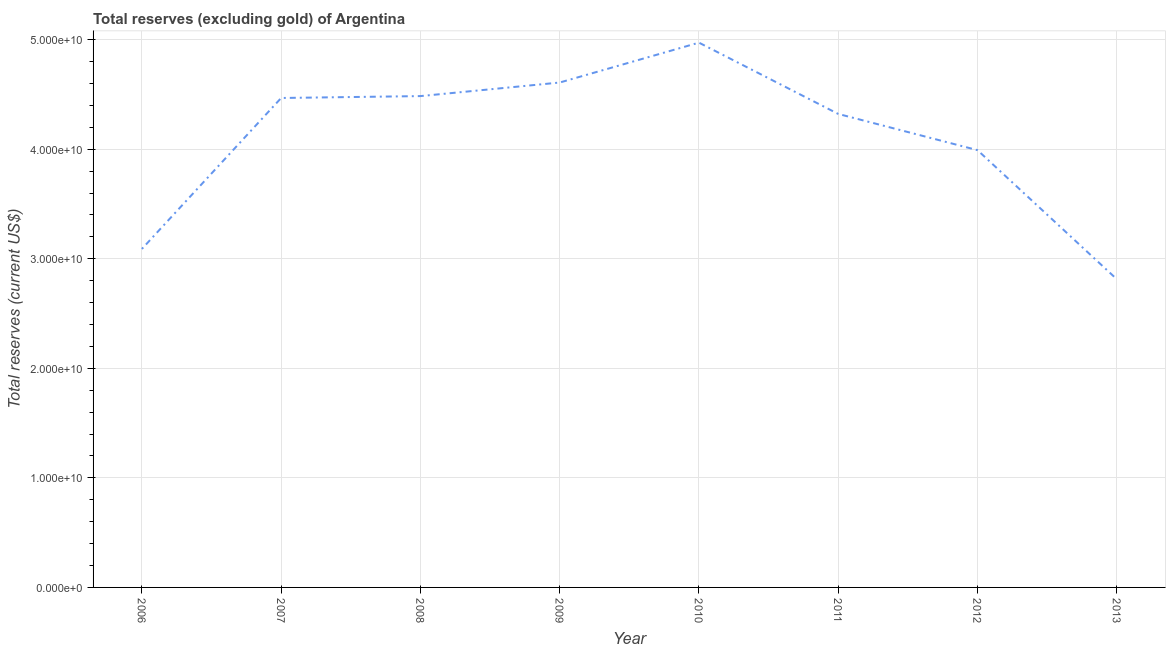What is the total reserves (excluding gold) in 2006?
Your answer should be very brief. 3.09e+1. Across all years, what is the maximum total reserves (excluding gold)?
Your answer should be very brief. 4.97e+1. Across all years, what is the minimum total reserves (excluding gold)?
Ensure brevity in your answer.  2.81e+1. What is the sum of the total reserves (excluding gold)?
Your answer should be compact. 3.28e+11. What is the difference between the total reserves (excluding gold) in 2006 and 2008?
Make the answer very short. -1.40e+1. What is the average total reserves (excluding gold) per year?
Keep it short and to the point. 4.09e+1. What is the median total reserves (excluding gold)?
Provide a short and direct response. 4.40e+1. What is the ratio of the total reserves (excluding gold) in 2007 to that in 2011?
Provide a short and direct response. 1.03. Is the difference between the total reserves (excluding gold) in 2006 and 2010 greater than the difference between any two years?
Give a very brief answer. No. What is the difference between the highest and the second highest total reserves (excluding gold)?
Provide a short and direct response. 3.64e+09. What is the difference between the highest and the lowest total reserves (excluding gold)?
Your answer should be compact. 2.16e+1. How many years are there in the graph?
Your answer should be very brief. 8. What is the difference between two consecutive major ticks on the Y-axis?
Ensure brevity in your answer.  1.00e+1. What is the title of the graph?
Provide a succinct answer. Total reserves (excluding gold) of Argentina. What is the label or title of the X-axis?
Your answer should be very brief. Year. What is the label or title of the Y-axis?
Ensure brevity in your answer.  Total reserves (current US$). What is the Total reserves (current US$) in 2006?
Your response must be concise. 3.09e+1. What is the Total reserves (current US$) of 2007?
Provide a succinct answer. 4.47e+1. What is the Total reserves (current US$) of 2008?
Offer a very short reply. 4.49e+1. What is the Total reserves (current US$) of 2009?
Your response must be concise. 4.61e+1. What is the Total reserves (current US$) of 2010?
Ensure brevity in your answer.  4.97e+1. What is the Total reserves (current US$) in 2011?
Keep it short and to the point. 4.32e+1. What is the Total reserves (current US$) of 2012?
Ensure brevity in your answer.  3.99e+1. What is the Total reserves (current US$) in 2013?
Your answer should be very brief. 2.81e+1. What is the difference between the Total reserves (current US$) in 2006 and 2007?
Give a very brief answer. -1.38e+1. What is the difference between the Total reserves (current US$) in 2006 and 2008?
Offer a terse response. -1.40e+1. What is the difference between the Total reserves (current US$) in 2006 and 2009?
Ensure brevity in your answer.  -1.52e+1. What is the difference between the Total reserves (current US$) in 2006 and 2010?
Offer a very short reply. -1.88e+1. What is the difference between the Total reserves (current US$) in 2006 and 2011?
Provide a succinct answer. -1.23e+1. What is the difference between the Total reserves (current US$) in 2006 and 2012?
Offer a very short reply. -9.02e+09. What is the difference between the Total reserves (current US$) in 2006 and 2013?
Provide a short and direct response. 2.76e+09. What is the difference between the Total reserves (current US$) in 2007 and 2008?
Make the answer very short. -1.73e+08. What is the difference between the Total reserves (current US$) in 2007 and 2009?
Your answer should be compact. -1.41e+09. What is the difference between the Total reserves (current US$) in 2007 and 2010?
Give a very brief answer. -5.05e+09. What is the difference between the Total reserves (current US$) in 2007 and 2011?
Ensure brevity in your answer.  1.46e+09. What is the difference between the Total reserves (current US$) in 2007 and 2012?
Make the answer very short. 4.76e+09. What is the difference between the Total reserves (current US$) in 2007 and 2013?
Offer a very short reply. 1.65e+1. What is the difference between the Total reserves (current US$) in 2008 and 2009?
Give a very brief answer. -1.24e+09. What is the difference between the Total reserves (current US$) in 2008 and 2010?
Your answer should be compact. -4.88e+09. What is the difference between the Total reserves (current US$) in 2008 and 2011?
Offer a terse response. 1.63e+09. What is the difference between the Total reserves (current US$) in 2008 and 2012?
Make the answer very short. 4.93e+09. What is the difference between the Total reserves (current US$) in 2008 and 2013?
Make the answer very short. 1.67e+1. What is the difference between the Total reserves (current US$) in 2009 and 2010?
Give a very brief answer. -3.64e+09. What is the difference between the Total reserves (current US$) in 2009 and 2011?
Keep it short and to the point. 2.87e+09. What is the difference between the Total reserves (current US$) in 2009 and 2012?
Make the answer very short. 6.17e+09. What is the difference between the Total reserves (current US$) in 2009 and 2013?
Your answer should be compact. 1.79e+1. What is the difference between the Total reserves (current US$) in 2010 and 2011?
Provide a succinct answer. 6.51e+09. What is the difference between the Total reserves (current US$) in 2010 and 2012?
Keep it short and to the point. 9.81e+09. What is the difference between the Total reserves (current US$) in 2010 and 2013?
Ensure brevity in your answer.  2.16e+1. What is the difference between the Total reserves (current US$) in 2011 and 2012?
Offer a very short reply. 3.31e+09. What is the difference between the Total reserves (current US$) in 2011 and 2013?
Make the answer very short. 1.51e+1. What is the difference between the Total reserves (current US$) in 2012 and 2013?
Make the answer very short. 1.18e+1. What is the ratio of the Total reserves (current US$) in 2006 to that in 2007?
Make the answer very short. 0.69. What is the ratio of the Total reserves (current US$) in 2006 to that in 2008?
Your response must be concise. 0.69. What is the ratio of the Total reserves (current US$) in 2006 to that in 2009?
Give a very brief answer. 0.67. What is the ratio of the Total reserves (current US$) in 2006 to that in 2010?
Make the answer very short. 0.62. What is the ratio of the Total reserves (current US$) in 2006 to that in 2011?
Your answer should be compact. 0.71. What is the ratio of the Total reserves (current US$) in 2006 to that in 2012?
Your answer should be compact. 0.77. What is the ratio of the Total reserves (current US$) in 2006 to that in 2013?
Offer a terse response. 1.1. What is the ratio of the Total reserves (current US$) in 2007 to that in 2010?
Your answer should be very brief. 0.9. What is the ratio of the Total reserves (current US$) in 2007 to that in 2011?
Give a very brief answer. 1.03. What is the ratio of the Total reserves (current US$) in 2007 to that in 2012?
Keep it short and to the point. 1.12. What is the ratio of the Total reserves (current US$) in 2007 to that in 2013?
Your answer should be compact. 1.59. What is the ratio of the Total reserves (current US$) in 2008 to that in 2009?
Your response must be concise. 0.97. What is the ratio of the Total reserves (current US$) in 2008 to that in 2010?
Provide a succinct answer. 0.9. What is the ratio of the Total reserves (current US$) in 2008 to that in 2011?
Offer a very short reply. 1.04. What is the ratio of the Total reserves (current US$) in 2008 to that in 2012?
Make the answer very short. 1.12. What is the ratio of the Total reserves (current US$) in 2008 to that in 2013?
Your response must be concise. 1.59. What is the ratio of the Total reserves (current US$) in 2009 to that in 2010?
Offer a terse response. 0.93. What is the ratio of the Total reserves (current US$) in 2009 to that in 2011?
Provide a short and direct response. 1.07. What is the ratio of the Total reserves (current US$) in 2009 to that in 2012?
Make the answer very short. 1.16. What is the ratio of the Total reserves (current US$) in 2009 to that in 2013?
Give a very brief answer. 1.64. What is the ratio of the Total reserves (current US$) in 2010 to that in 2011?
Your response must be concise. 1.15. What is the ratio of the Total reserves (current US$) in 2010 to that in 2012?
Provide a short and direct response. 1.25. What is the ratio of the Total reserves (current US$) in 2010 to that in 2013?
Keep it short and to the point. 1.77. What is the ratio of the Total reserves (current US$) in 2011 to that in 2012?
Give a very brief answer. 1.08. What is the ratio of the Total reserves (current US$) in 2011 to that in 2013?
Ensure brevity in your answer.  1.54. What is the ratio of the Total reserves (current US$) in 2012 to that in 2013?
Offer a very short reply. 1.42. 